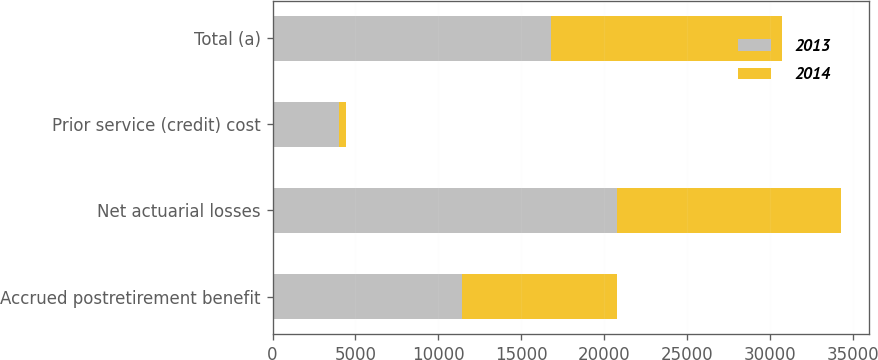Convert chart. <chart><loc_0><loc_0><loc_500><loc_500><stacked_bar_chart><ecel><fcel>Accrued postretirement benefit<fcel>Net actuarial losses<fcel>Prior service (credit) cost<fcel>Total (a)<nl><fcel>2013<fcel>11413<fcel>20794<fcel>3985<fcel>16809<nl><fcel>2014<fcel>9361<fcel>13453<fcel>443<fcel>13896<nl></chart> 